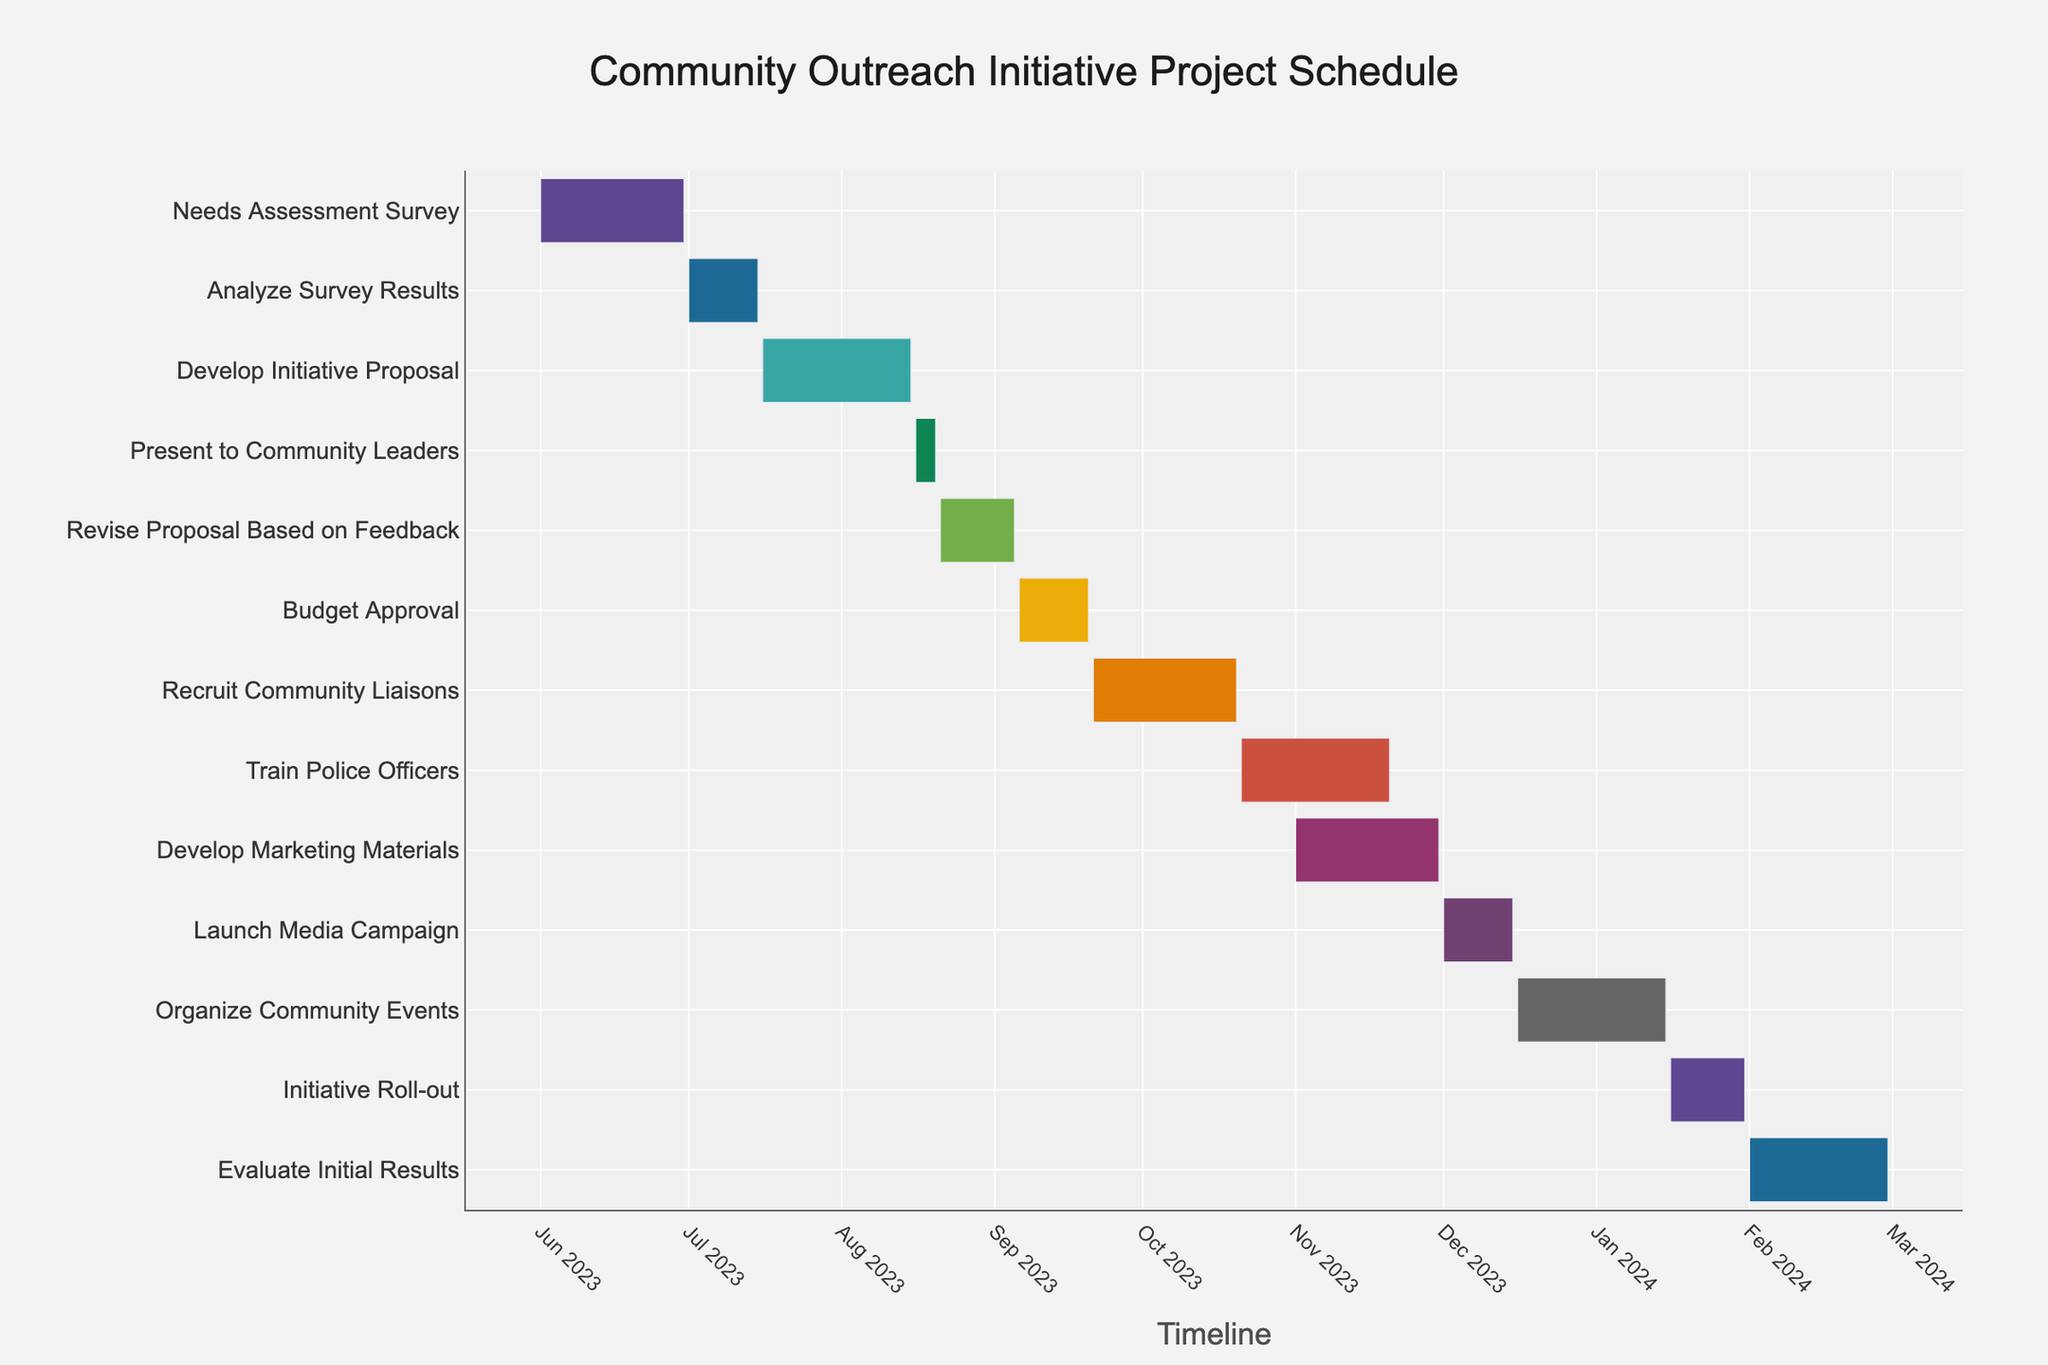What's the title of the project schedule chart? The title of the plot is prominently displayed at the top of the figure.
Answer: Community Outreach Initiative Project Schedule How many tasks are listed in the project schedule? The Gantt chart has multiple bars, each representing a task. Count the tasks to get the total number.
Answer: 13 Which task takes the longest duration? Look for the bar that stretches the furthest along the timeline.
Answer: Develop Initiative Proposal and Train Police Officers What is the duration of the "Train Police Officers" task? Find the bar labeled "Train Police Officers" and check the hover information for the duration.
Answer: 31 days Which tasks are scheduled to start in December 2023? Identify the tasks whose bars begin in December 2023.
Answer: Launch Media Campaign and Organize Community Events When does the "Launch Media Campaign" task start and end? Locate the bar for "Launch Media Campaign" and check its start and end points on the timeline.
Answer: Starts on December 1, 2023, and ends on December 15, 2023 How long is the gap between the end of "Recruit Community Liaisons" and the start of "Train Police Officers"? Find the end date of "Recruit Community Liaisons" and the start date of "Train Police Officers." Calculate the difference in days.
Answer: 0 days (both tasks are consecutive) Which task immediately follows "Analyze Survey Results"? Look at the timeline and find the task that starts right after "Analyze Survey Results" ends.
Answer: Develop Initiative Proposal How many days does it take to evaluate the initial results of the initiative? Find the bar for "Evaluate Initial Results" and check the duration mentioned in the hover information.
Answer: 29 days What is the start date of the first task and end date of the last task in the schedule? Locate the starting point of the first bar and the end point of the last bar on the timeline.
Answer: Starts on June 1, 2023, and ends on February 29, 2024 